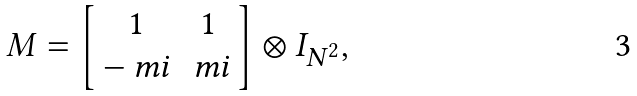<formula> <loc_0><loc_0><loc_500><loc_500>M = \left [ \begin{array} { c c } 1 & 1 \\ - \ m i & \ m i \end{array} \right ] \otimes I _ { N ^ { 2 } } ,</formula> 